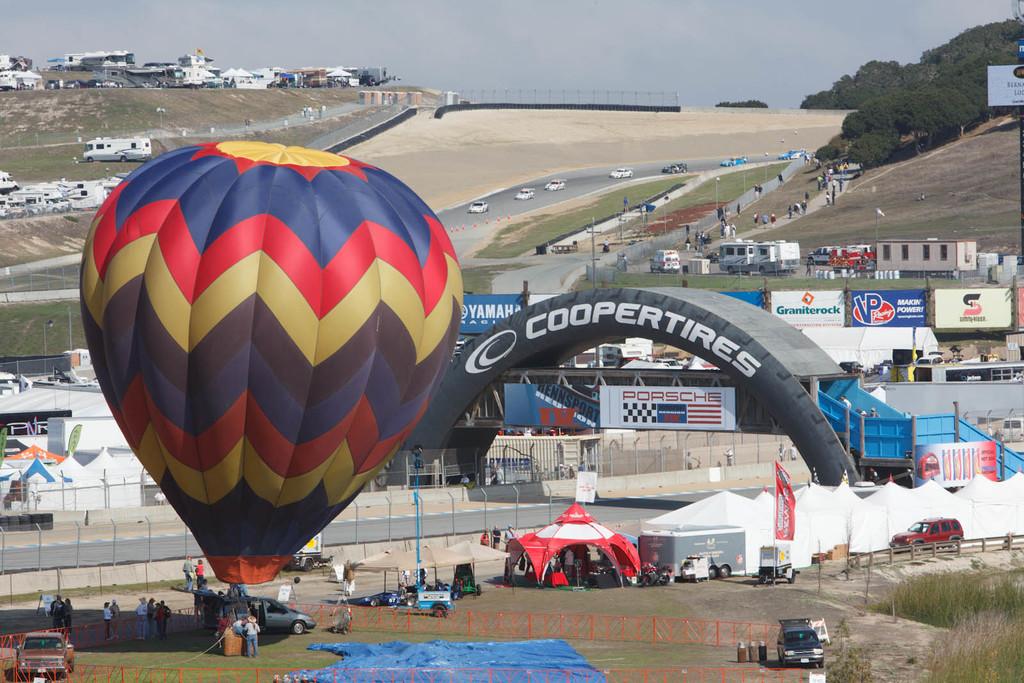Is this a car race?
Keep it short and to the point. Yes. What brand of tires is on the arch?
Offer a terse response. Coopertires. 